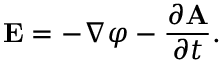Convert formula to latex. <formula><loc_0><loc_0><loc_500><loc_500>E = - \nabla \varphi - { \frac { \partial A } { \partial t } } .</formula> 